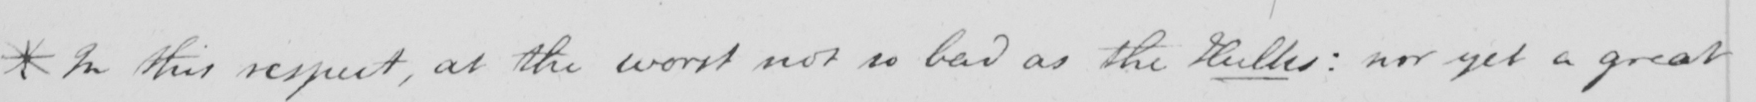Please transcribe the handwritten text in this image. *In this respect , at the worst not as bad as the Hulks :  nor yet a great 